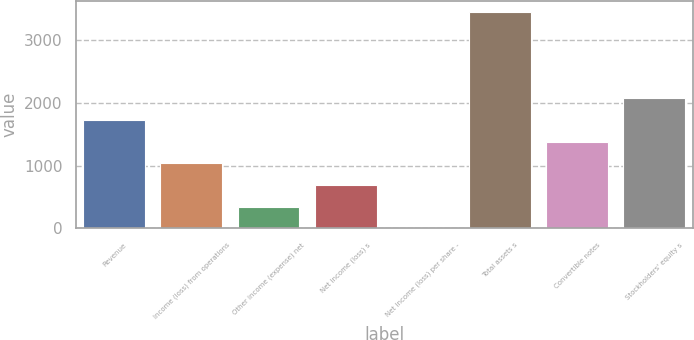Convert chart to OTSL. <chart><loc_0><loc_0><loc_500><loc_500><bar_chart><fcel>Revenue<fcel>Income (loss) from operations<fcel>Other income (expense) net<fcel>Net income (loss) s<fcel>Net income (loss) per share -<fcel>Total assets s<fcel>Convertible notes<fcel>Stockholders' equity s<nl><fcel>1721.61<fcel>1033.15<fcel>344.69<fcel>688.92<fcel>0.46<fcel>3442.8<fcel>1377.38<fcel>2065.84<nl></chart> 